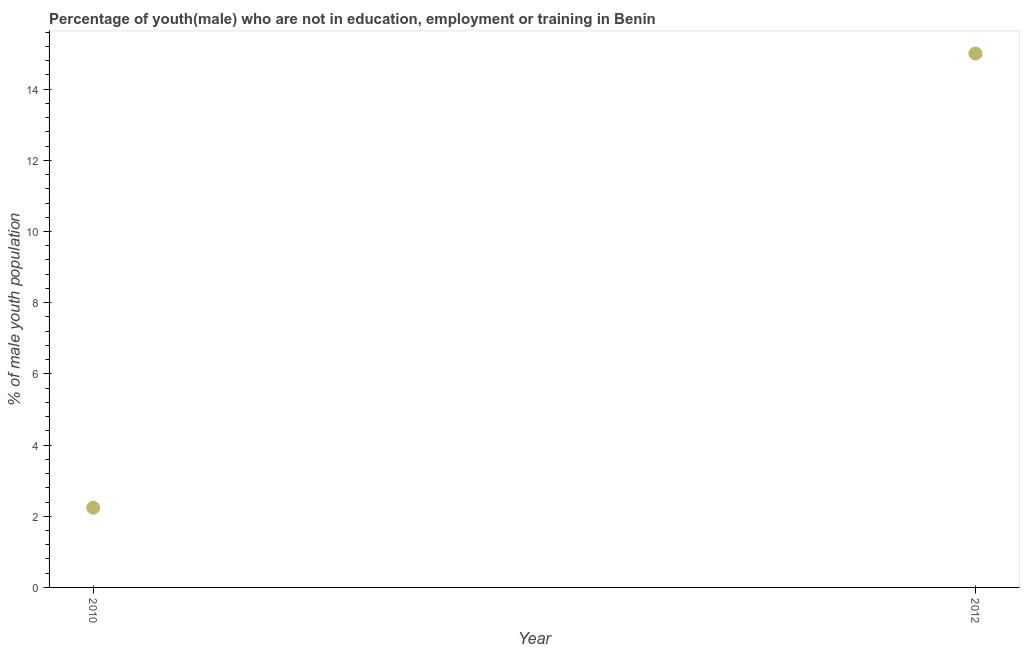What is the unemployed male youth population in 2012?
Give a very brief answer. 15. Across all years, what is the minimum unemployed male youth population?
Offer a terse response. 2.24. In which year was the unemployed male youth population maximum?
Provide a short and direct response. 2012. What is the sum of the unemployed male youth population?
Keep it short and to the point. 17.24. What is the difference between the unemployed male youth population in 2010 and 2012?
Give a very brief answer. -12.76. What is the average unemployed male youth population per year?
Keep it short and to the point. 8.62. What is the median unemployed male youth population?
Give a very brief answer. 8.62. Do a majority of the years between 2012 and 2010 (inclusive) have unemployed male youth population greater than 9.6 %?
Give a very brief answer. No. What is the ratio of the unemployed male youth population in 2010 to that in 2012?
Ensure brevity in your answer.  0.15. Is the unemployed male youth population in 2010 less than that in 2012?
Make the answer very short. Yes. How many dotlines are there?
Offer a very short reply. 1. How many years are there in the graph?
Your answer should be compact. 2. What is the title of the graph?
Ensure brevity in your answer.  Percentage of youth(male) who are not in education, employment or training in Benin. What is the label or title of the X-axis?
Offer a terse response. Year. What is the label or title of the Y-axis?
Your answer should be very brief. % of male youth population. What is the % of male youth population in 2010?
Provide a succinct answer. 2.24. What is the difference between the % of male youth population in 2010 and 2012?
Provide a short and direct response. -12.76. What is the ratio of the % of male youth population in 2010 to that in 2012?
Make the answer very short. 0.15. 